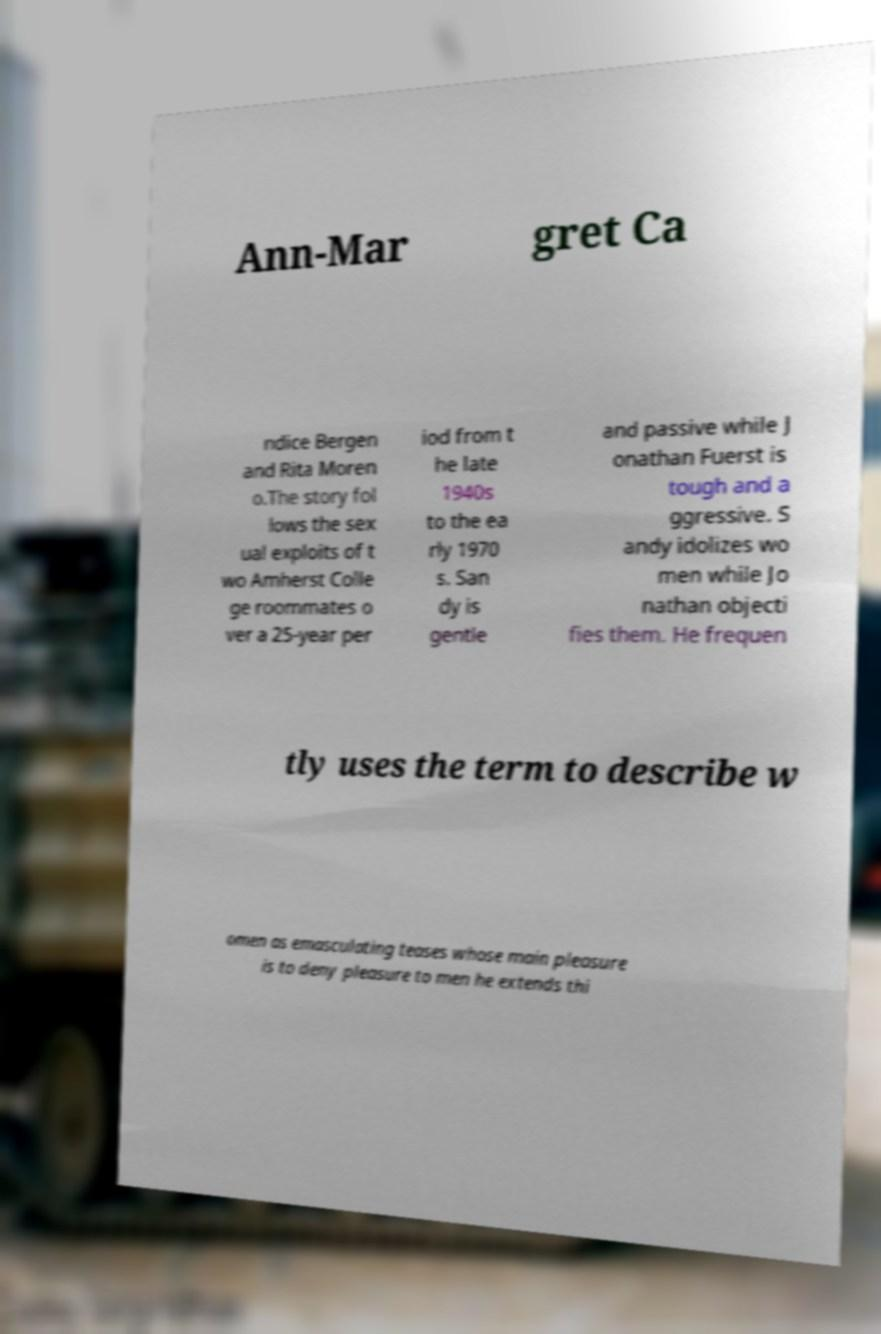Can you accurately transcribe the text from the provided image for me? Ann-Mar gret Ca ndice Bergen and Rita Moren o.The story fol lows the sex ual exploits of t wo Amherst Colle ge roommates o ver a 25-year per iod from t he late 1940s to the ea rly 1970 s. San dy is gentle and passive while J onathan Fuerst is tough and a ggressive. S andy idolizes wo men while Jo nathan objecti fies them. He frequen tly uses the term to describe w omen as emasculating teases whose main pleasure is to deny pleasure to men he extends thi 